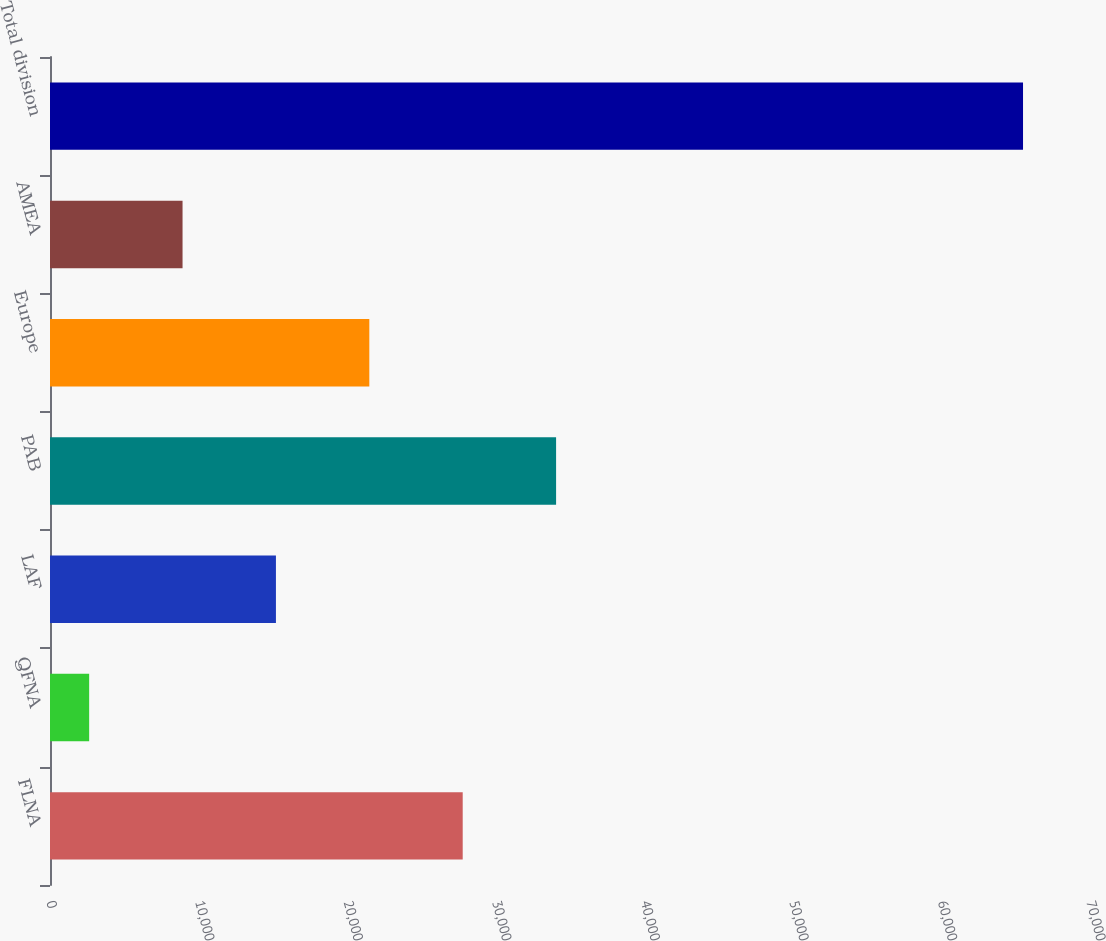Convert chart to OTSL. <chart><loc_0><loc_0><loc_500><loc_500><bar_chart><fcel>FLNA<fcel>QFNA<fcel>LAF<fcel>PAB<fcel>Europe<fcel>AMEA<fcel>Total division<nl><fcel>27778.4<fcel>2636<fcel>15207.2<fcel>34064<fcel>21492.8<fcel>8921.6<fcel>65492<nl></chart> 